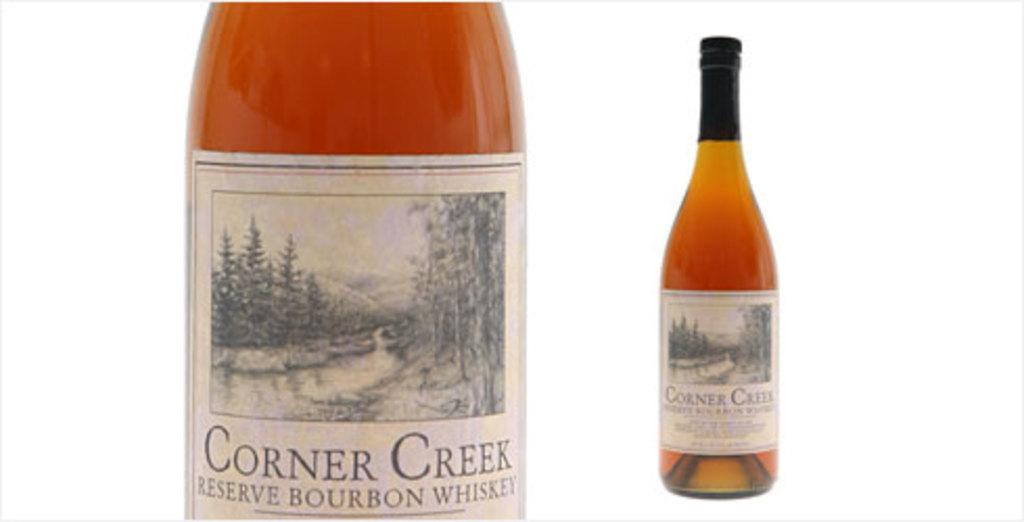<image>
Create a compact narrative representing the image presented. Two bottles of Corner Creek Reserve Bourbon Whisky on a white background 